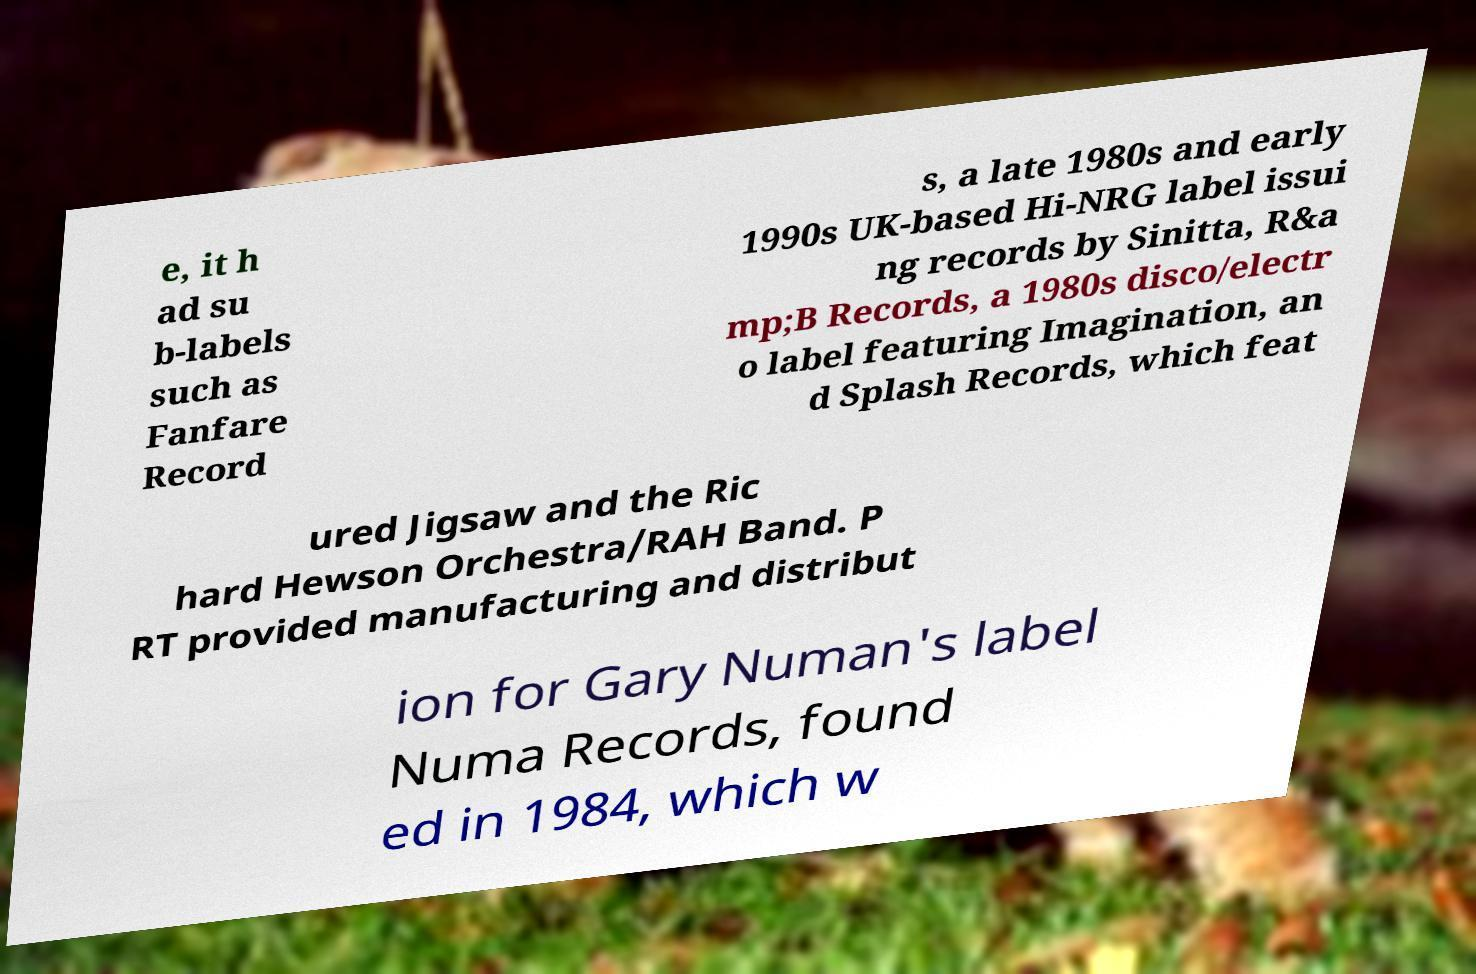For documentation purposes, I need the text within this image transcribed. Could you provide that? e, it h ad su b-labels such as Fanfare Record s, a late 1980s and early 1990s UK-based Hi-NRG label issui ng records by Sinitta, R&a mp;B Records, a 1980s disco/electr o label featuring Imagination, an d Splash Records, which feat ured Jigsaw and the Ric hard Hewson Orchestra/RAH Band. P RT provided manufacturing and distribut ion for Gary Numan's label Numa Records, found ed in 1984, which w 